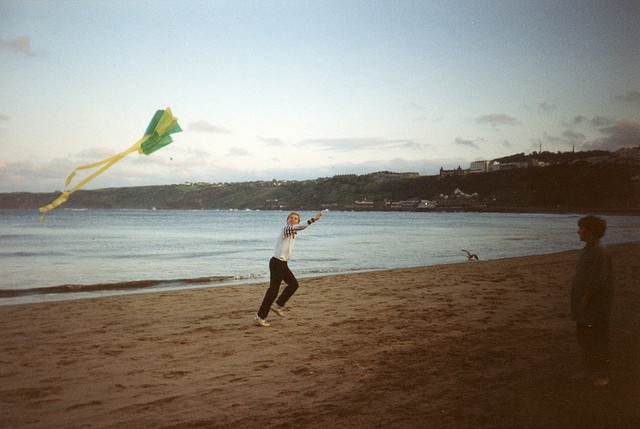Describe the objects in this image and their specific colors. I can see people in darkgray, black, maroon, and gray tones, people in darkgray, black, gray, and tan tones, kite in darkgray, olive, green, and tan tones, and bird in darkgray, maroon, gray, and black tones in this image. 